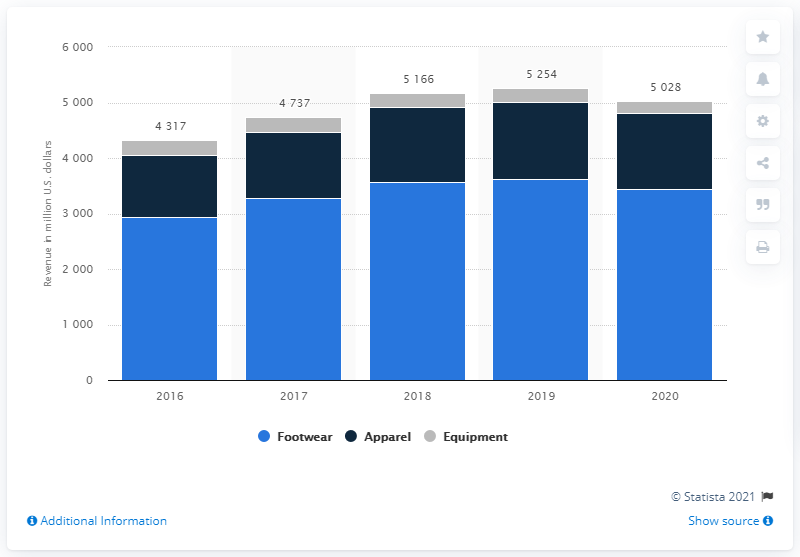Specify some key components in this picture. In 2020, Nike's footwear revenue from the Asia Pacific and Latin America regions was approximately $3,449 million. 